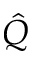<formula> <loc_0><loc_0><loc_500><loc_500>\hat { Q }</formula> 